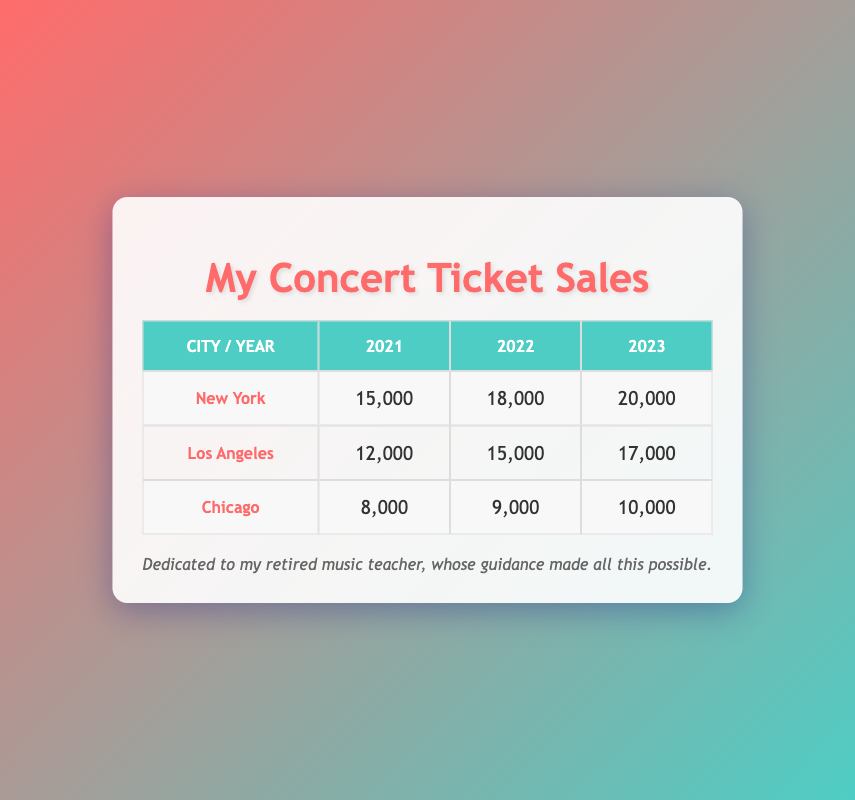What was the total number of tickets sold in New York in 2021? In the table, the number of tickets sold in New York for the year 2021 is listed as 15,000.
Answer: 15,000 Which city had the highest ticket sales in 2023? For the year 2023, New York sold 20,000 tickets, Los Angeles sold 17,000 tickets, and Chicago sold 10,000 tickets. New York has the highest number.
Answer: New York What was the overall ticket sales increase from 2021 to 2022 in Chicago? In 2021, Chicago sold 8,000 tickets and in 2022, it sold 9,000 tickets. The increase is 9,000 - 8,000 = 1,000.
Answer: 1,000 Did Los Angeles show an increase in ticket sales from 2021 to 2023? In 2021, Los Angeles sold 12,000 tickets, and by 2023, this number increased to 17,000. Since 17,000 is greater than 12,000, this is true.
Answer: Yes What is the average number of tickets sold per year in New York? For New York, the tickets sold were 15,000 in 2021, 18,000 in 2022, and 20,000 in 2023. The average is (15,000 + 18,000 + 20,000) / 3 = 53,000 / 3 = 17,666.67.
Answer: 17,666.67 In which year did Chicago sell the least number of tickets? The tickets sold in Chicago were 8,000 in 2021, 9,000 in 2022, and 10,000 in 2023. 2021 has the least number of tickets sold.
Answer: 2021 What was the difference in ticket sales between Los Angeles in 2022 and 2023? Los Angeles sold 15,000 tickets in 2022 and 17,000 tickets in 2023. The difference is 17,000 - 15,000 = 2,000.
Answer: 2,000 Which city had consistent growth in ticket sales from 2021 to 2023? Looking at each year's sales: New York (15,000, 18,000, 20,000), Los Angeles (12,000, 15,000, 17,000), and Chicago (8,000, 9,000, 10,000). All three cities grew, but New York had the most significant and consistent growth each year.
Answer: New York What was the total number of tickets sold across all cities in 2022? In 2022, New York sold 18,000, Los Angeles sold 15,000, and Chicago sold 9,000. The total is 18,000 + 15,000 + 9,000 = 42,000.
Answer: 42,000 